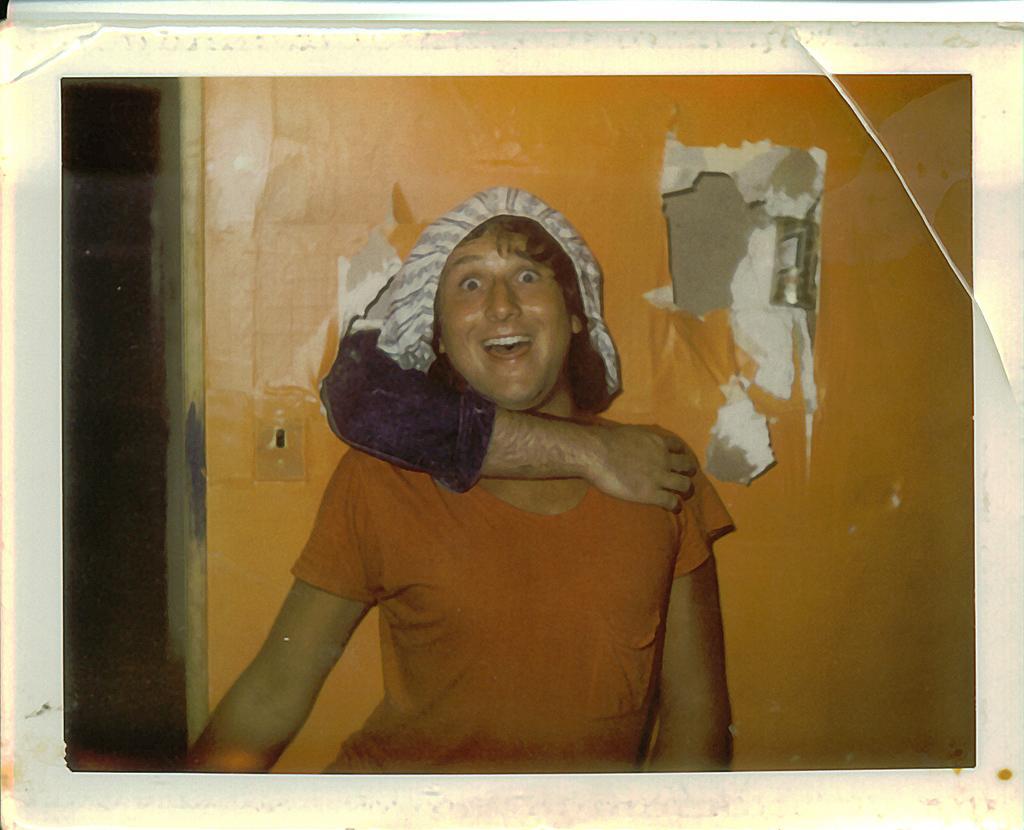In one or two sentences, can you explain what this image depicts? In this image we can see a person standing and smiling. Back of the person there is a wall, from the wall there is a hand holding the person. 